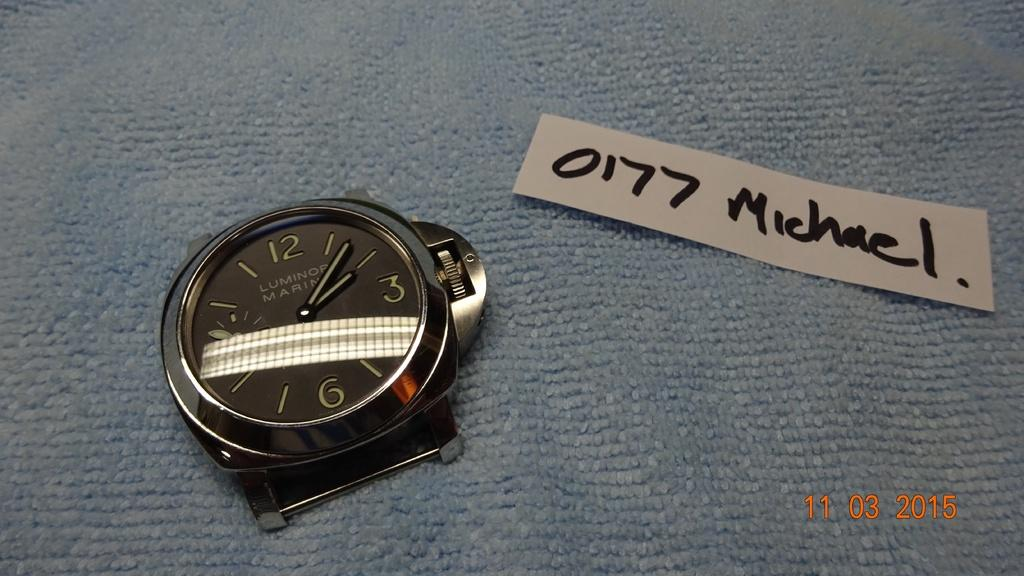Provide a one-sentence caption for the provided image. A WATCH WITH NO BAND AND A WHITE TAG SAYING 0177 MICHAEL. 